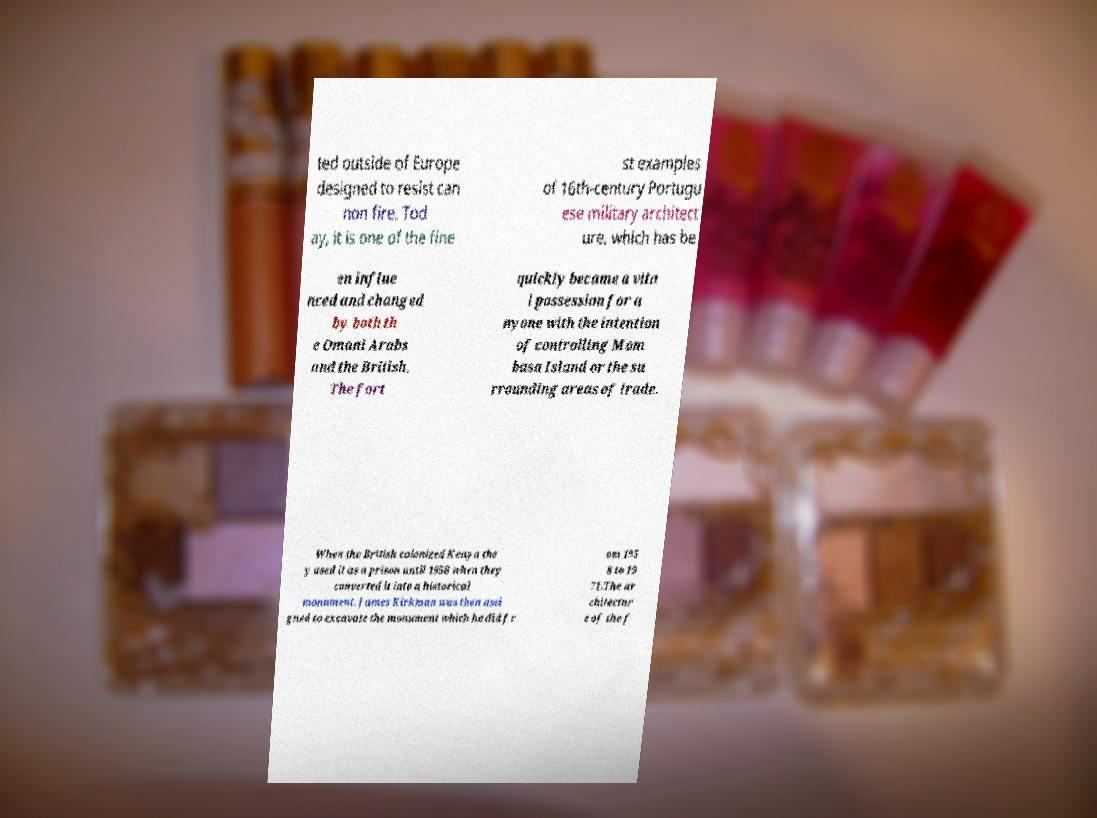Please read and relay the text visible in this image. What does it say? ted outside of Europe designed to resist can non fire. Tod ay, it is one of the fine st examples of 16th-century Portugu ese military architect ure, which has be en influe nced and changed by both th e Omani Arabs and the British. The fort quickly became a vita l possession for a nyone with the intention of controlling Mom basa Island or the su rrounding areas of trade. When the British colonized Kenya the y used it as a prison until 1958 when they converted it into a historical monument. James Kirkman was then assi gned to excavate the monument which he did fr om 195 8 to 19 71.The ar chitectur e of the f 